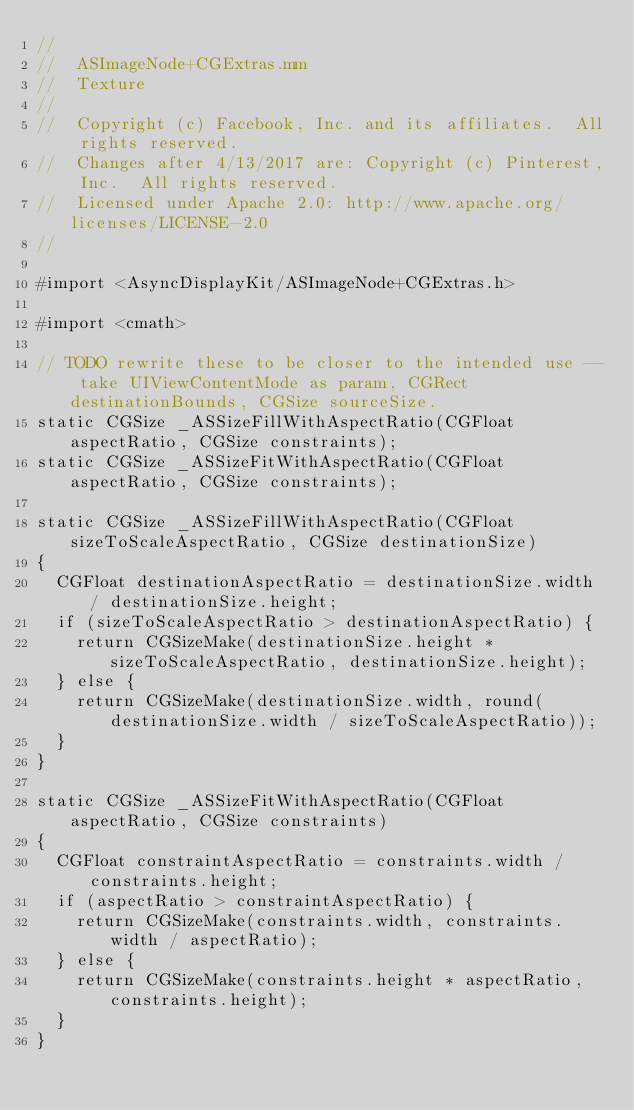Convert code to text. <code><loc_0><loc_0><loc_500><loc_500><_ObjectiveC_>//
//  ASImageNode+CGExtras.mm
//  Texture
//
//  Copyright (c) Facebook, Inc. and its affiliates.  All rights reserved.
//  Changes after 4/13/2017 are: Copyright (c) Pinterest, Inc.  All rights reserved.
//  Licensed under Apache 2.0: http://www.apache.org/licenses/LICENSE-2.0
//

#import <AsyncDisplayKit/ASImageNode+CGExtras.h>

#import <cmath>

// TODO rewrite these to be closer to the intended use -- take UIViewContentMode as param, CGRect destinationBounds, CGSize sourceSize.
static CGSize _ASSizeFillWithAspectRatio(CGFloat aspectRatio, CGSize constraints);
static CGSize _ASSizeFitWithAspectRatio(CGFloat aspectRatio, CGSize constraints);

static CGSize _ASSizeFillWithAspectRatio(CGFloat sizeToScaleAspectRatio, CGSize destinationSize)
{
  CGFloat destinationAspectRatio = destinationSize.width / destinationSize.height;
  if (sizeToScaleAspectRatio > destinationAspectRatio) {
    return CGSizeMake(destinationSize.height * sizeToScaleAspectRatio, destinationSize.height);
  } else {
    return CGSizeMake(destinationSize.width, round(destinationSize.width / sizeToScaleAspectRatio));
  }
}

static CGSize _ASSizeFitWithAspectRatio(CGFloat aspectRatio, CGSize constraints)
{
  CGFloat constraintAspectRatio = constraints.width / constraints.height;
  if (aspectRatio > constraintAspectRatio) {
    return CGSizeMake(constraints.width, constraints.width / aspectRatio);
  } else {
    return CGSizeMake(constraints.height * aspectRatio, constraints.height);
  }
}
</code> 